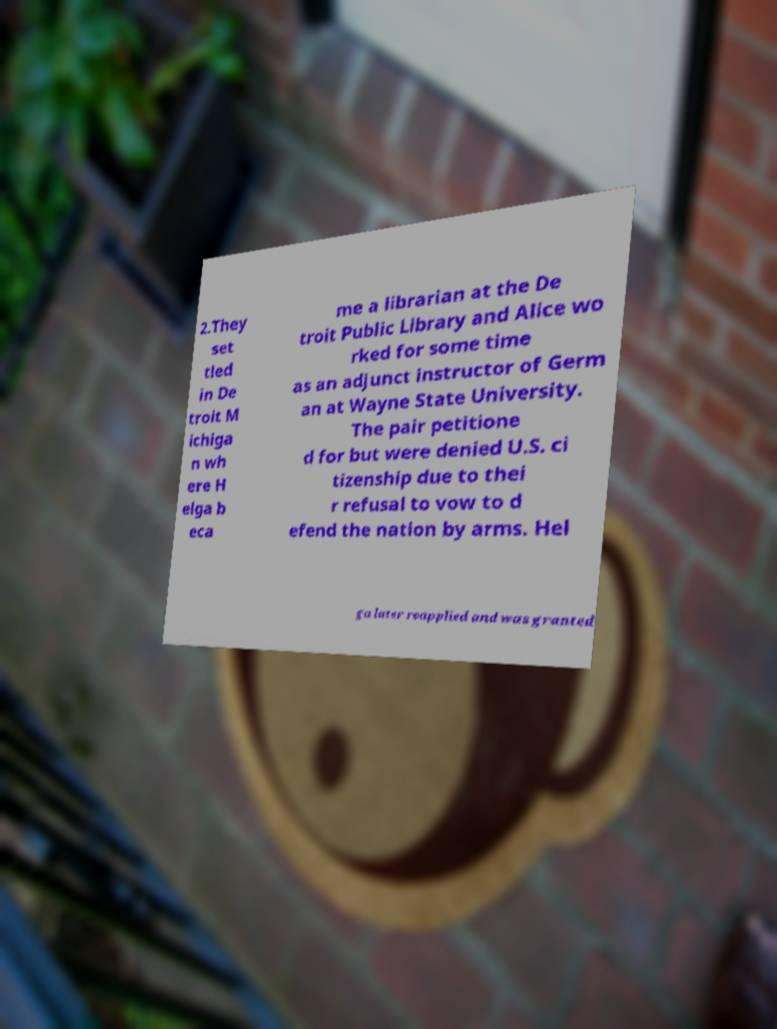Please read and relay the text visible in this image. What does it say? 2.They set tled in De troit M ichiga n wh ere H elga b eca me a librarian at the De troit Public Library and Alice wo rked for some time as an adjunct instructor of Germ an at Wayne State University. The pair petitione d for but were denied U.S. ci tizenship due to thei r refusal to vow to d efend the nation by arms. Hel ga later reapplied and was granted 